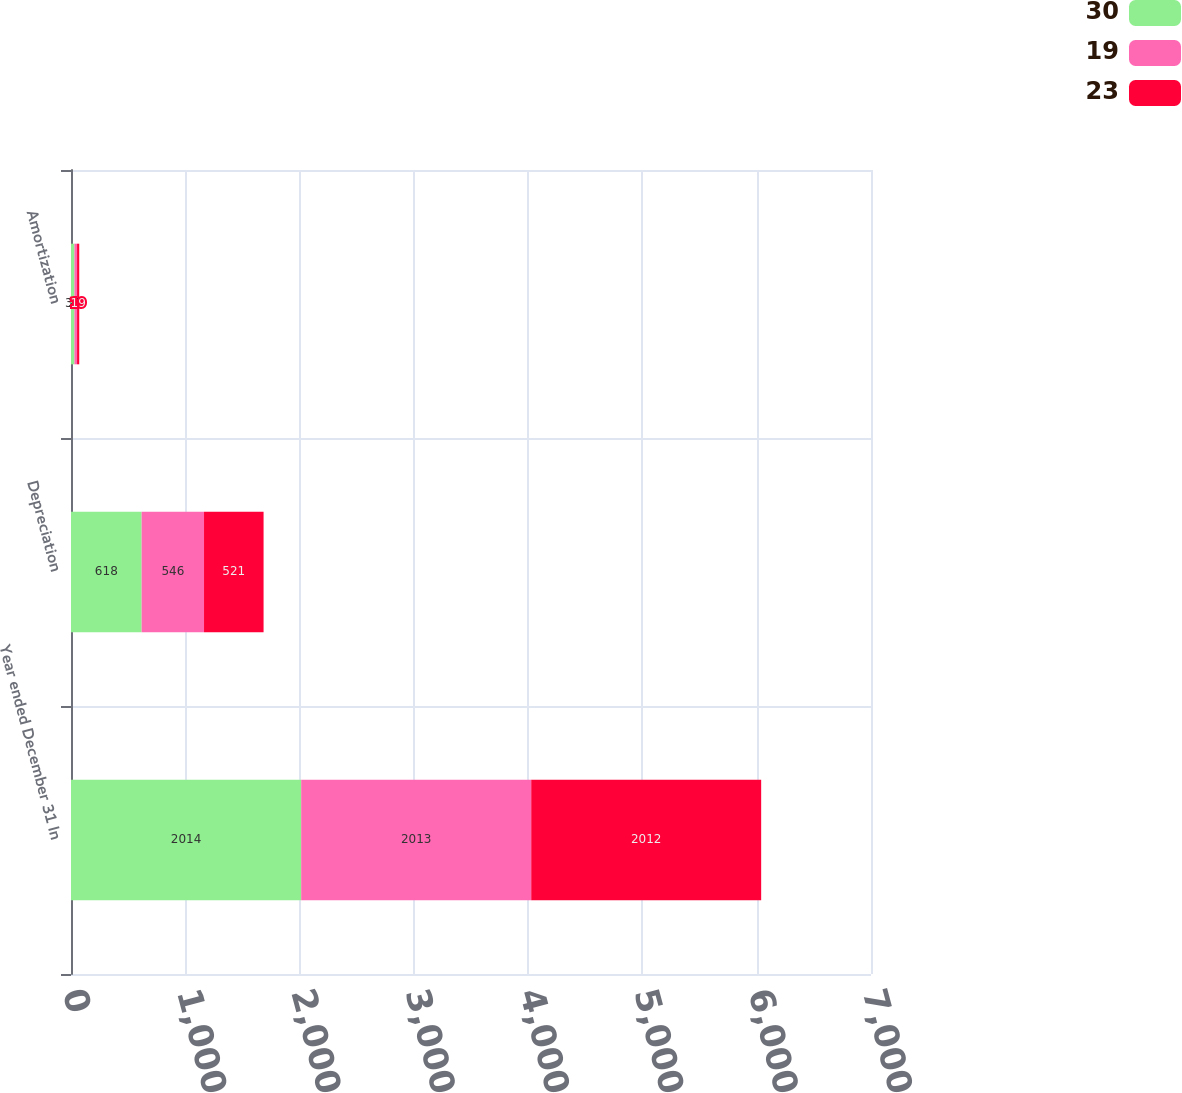Convert chart. <chart><loc_0><loc_0><loc_500><loc_500><stacked_bar_chart><ecel><fcel>Year ended December 31 In<fcel>Depreciation<fcel>Amortization<nl><fcel>30<fcel>2014<fcel>618<fcel>30<nl><fcel>19<fcel>2013<fcel>546<fcel>23<nl><fcel>23<fcel>2012<fcel>521<fcel>19<nl></chart> 